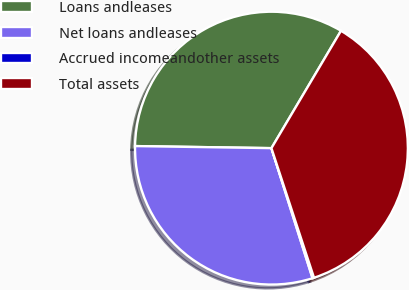Convert chart to OTSL. <chart><loc_0><loc_0><loc_500><loc_500><pie_chart><fcel>Loans andleases<fcel>Net loans andleases<fcel>Accrued incomeandother assets<fcel>Total assets<nl><fcel>33.27%<fcel>30.11%<fcel>0.18%<fcel>36.43%<nl></chart> 